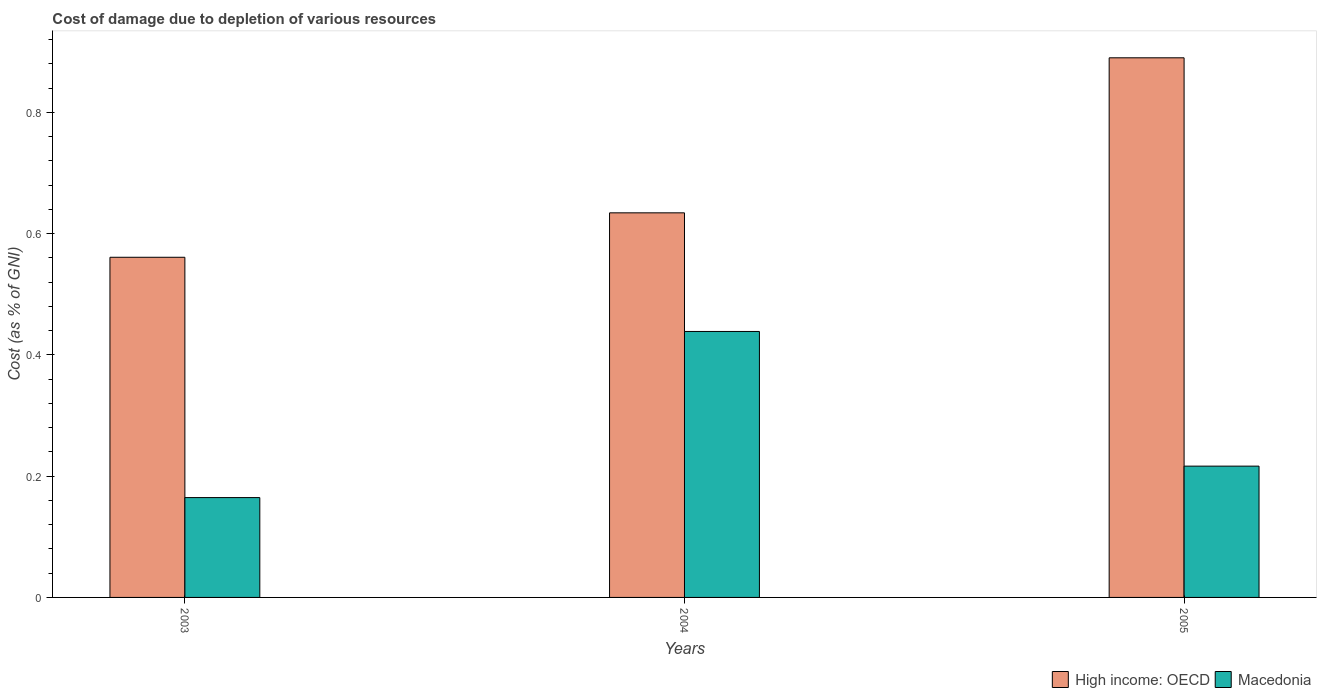How many groups of bars are there?
Offer a terse response. 3. Are the number of bars per tick equal to the number of legend labels?
Make the answer very short. Yes. How many bars are there on the 1st tick from the left?
Give a very brief answer. 2. What is the cost of damage caused due to the depletion of various resources in Macedonia in 2003?
Provide a succinct answer. 0.16. Across all years, what is the maximum cost of damage caused due to the depletion of various resources in High income: OECD?
Keep it short and to the point. 0.89. Across all years, what is the minimum cost of damage caused due to the depletion of various resources in Macedonia?
Your response must be concise. 0.16. What is the total cost of damage caused due to the depletion of various resources in Macedonia in the graph?
Make the answer very short. 0.82. What is the difference between the cost of damage caused due to the depletion of various resources in Macedonia in 2003 and that in 2005?
Ensure brevity in your answer.  -0.05. What is the difference between the cost of damage caused due to the depletion of various resources in High income: OECD in 2003 and the cost of damage caused due to the depletion of various resources in Macedonia in 2004?
Provide a short and direct response. 0.12. What is the average cost of damage caused due to the depletion of various resources in High income: OECD per year?
Ensure brevity in your answer.  0.7. In the year 2005, what is the difference between the cost of damage caused due to the depletion of various resources in Macedonia and cost of damage caused due to the depletion of various resources in High income: OECD?
Your response must be concise. -0.67. In how many years, is the cost of damage caused due to the depletion of various resources in Macedonia greater than 0.7600000000000001 %?
Ensure brevity in your answer.  0. What is the ratio of the cost of damage caused due to the depletion of various resources in High income: OECD in 2003 to that in 2005?
Your response must be concise. 0.63. Is the cost of damage caused due to the depletion of various resources in High income: OECD in 2003 less than that in 2004?
Provide a succinct answer. Yes. Is the difference between the cost of damage caused due to the depletion of various resources in Macedonia in 2003 and 2005 greater than the difference between the cost of damage caused due to the depletion of various resources in High income: OECD in 2003 and 2005?
Provide a succinct answer. Yes. What is the difference between the highest and the second highest cost of damage caused due to the depletion of various resources in High income: OECD?
Offer a terse response. 0.26. What is the difference between the highest and the lowest cost of damage caused due to the depletion of various resources in High income: OECD?
Give a very brief answer. 0.33. Is the sum of the cost of damage caused due to the depletion of various resources in High income: OECD in 2003 and 2004 greater than the maximum cost of damage caused due to the depletion of various resources in Macedonia across all years?
Your answer should be very brief. Yes. What does the 1st bar from the left in 2005 represents?
Your answer should be compact. High income: OECD. What does the 1st bar from the right in 2004 represents?
Your response must be concise. Macedonia. How many bars are there?
Keep it short and to the point. 6. Are all the bars in the graph horizontal?
Provide a short and direct response. No. How many years are there in the graph?
Your answer should be compact. 3. Does the graph contain grids?
Provide a succinct answer. No. Where does the legend appear in the graph?
Make the answer very short. Bottom right. How many legend labels are there?
Offer a terse response. 2. How are the legend labels stacked?
Your answer should be compact. Horizontal. What is the title of the graph?
Provide a short and direct response. Cost of damage due to depletion of various resources. Does "Isle of Man" appear as one of the legend labels in the graph?
Offer a very short reply. No. What is the label or title of the X-axis?
Make the answer very short. Years. What is the label or title of the Y-axis?
Your response must be concise. Cost (as % of GNI). What is the Cost (as % of GNI) of High income: OECD in 2003?
Ensure brevity in your answer.  0.56. What is the Cost (as % of GNI) of Macedonia in 2003?
Your answer should be very brief. 0.16. What is the Cost (as % of GNI) in High income: OECD in 2004?
Ensure brevity in your answer.  0.63. What is the Cost (as % of GNI) in Macedonia in 2004?
Your answer should be compact. 0.44. What is the Cost (as % of GNI) of High income: OECD in 2005?
Make the answer very short. 0.89. What is the Cost (as % of GNI) of Macedonia in 2005?
Provide a succinct answer. 0.22. Across all years, what is the maximum Cost (as % of GNI) of High income: OECD?
Your answer should be compact. 0.89. Across all years, what is the maximum Cost (as % of GNI) of Macedonia?
Provide a short and direct response. 0.44. Across all years, what is the minimum Cost (as % of GNI) in High income: OECD?
Make the answer very short. 0.56. Across all years, what is the minimum Cost (as % of GNI) in Macedonia?
Ensure brevity in your answer.  0.16. What is the total Cost (as % of GNI) in High income: OECD in the graph?
Keep it short and to the point. 2.09. What is the total Cost (as % of GNI) in Macedonia in the graph?
Offer a very short reply. 0.82. What is the difference between the Cost (as % of GNI) in High income: OECD in 2003 and that in 2004?
Make the answer very short. -0.07. What is the difference between the Cost (as % of GNI) in Macedonia in 2003 and that in 2004?
Provide a succinct answer. -0.27. What is the difference between the Cost (as % of GNI) of High income: OECD in 2003 and that in 2005?
Your answer should be compact. -0.33. What is the difference between the Cost (as % of GNI) of Macedonia in 2003 and that in 2005?
Offer a very short reply. -0.05. What is the difference between the Cost (as % of GNI) of High income: OECD in 2004 and that in 2005?
Your answer should be compact. -0.26. What is the difference between the Cost (as % of GNI) in Macedonia in 2004 and that in 2005?
Your answer should be very brief. 0.22. What is the difference between the Cost (as % of GNI) of High income: OECD in 2003 and the Cost (as % of GNI) of Macedonia in 2004?
Provide a succinct answer. 0.12. What is the difference between the Cost (as % of GNI) of High income: OECD in 2003 and the Cost (as % of GNI) of Macedonia in 2005?
Your answer should be very brief. 0.34. What is the difference between the Cost (as % of GNI) of High income: OECD in 2004 and the Cost (as % of GNI) of Macedonia in 2005?
Keep it short and to the point. 0.42. What is the average Cost (as % of GNI) in High income: OECD per year?
Provide a succinct answer. 0.69. What is the average Cost (as % of GNI) of Macedonia per year?
Your answer should be compact. 0.27. In the year 2003, what is the difference between the Cost (as % of GNI) in High income: OECD and Cost (as % of GNI) in Macedonia?
Provide a short and direct response. 0.4. In the year 2004, what is the difference between the Cost (as % of GNI) of High income: OECD and Cost (as % of GNI) of Macedonia?
Your answer should be very brief. 0.2. In the year 2005, what is the difference between the Cost (as % of GNI) in High income: OECD and Cost (as % of GNI) in Macedonia?
Provide a succinct answer. 0.67. What is the ratio of the Cost (as % of GNI) of High income: OECD in 2003 to that in 2004?
Give a very brief answer. 0.88. What is the ratio of the Cost (as % of GNI) in Macedonia in 2003 to that in 2004?
Offer a terse response. 0.38. What is the ratio of the Cost (as % of GNI) of High income: OECD in 2003 to that in 2005?
Ensure brevity in your answer.  0.63. What is the ratio of the Cost (as % of GNI) of Macedonia in 2003 to that in 2005?
Make the answer very short. 0.76. What is the ratio of the Cost (as % of GNI) of High income: OECD in 2004 to that in 2005?
Offer a terse response. 0.71. What is the ratio of the Cost (as % of GNI) of Macedonia in 2004 to that in 2005?
Make the answer very short. 2.03. What is the difference between the highest and the second highest Cost (as % of GNI) in High income: OECD?
Keep it short and to the point. 0.26. What is the difference between the highest and the second highest Cost (as % of GNI) of Macedonia?
Make the answer very short. 0.22. What is the difference between the highest and the lowest Cost (as % of GNI) of High income: OECD?
Provide a succinct answer. 0.33. What is the difference between the highest and the lowest Cost (as % of GNI) in Macedonia?
Provide a short and direct response. 0.27. 